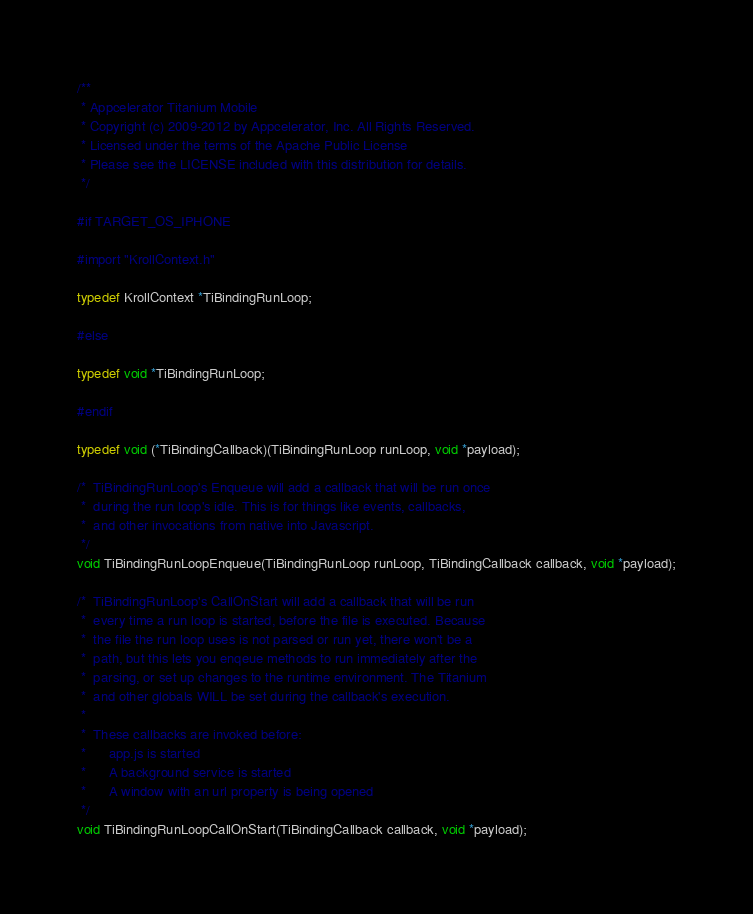<code> <loc_0><loc_0><loc_500><loc_500><_C_>/**
 * Appcelerator Titanium Mobile
 * Copyright (c) 2009-2012 by Appcelerator, Inc. All Rights Reserved.
 * Licensed under the terms of the Apache Public License
 * Please see the LICENSE included with this distribution for details.
 */

#if TARGET_OS_IPHONE

#import "KrollContext.h"

typedef KrollContext *TiBindingRunLoop;

#else

typedef void *TiBindingRunLoop;

#endif

typedef void (*TiBindingCallback)(TiBindingRunLoop runLoop, void *payload);

/*	TiBindingRunLoop's Enqueue will add a callback that will be run once
 *	during the run loop's idle. This is for things like events, callbacks,
 *	and other invocations from native into Javascript.
 */
void TiBindingRunLoopEnqueue(TiBindingRunLoop runLoop, TiBindingCallback callback, void *payload);

/*	TiBindingRunLoop's CallOnStart will add a callback that will be run
 *	every time a run loop is started, before the file is executed. Because
 *	the file the run loop uses is not parsed or run yet, there won't be a
 *	path, but this lets you enqeue methods to run immediately after the
 *	parsing, or set up changes to the runtime environment. The Titanium
 *	and other globals WILL be set during the callback's execution.
 *
 *	These callbacks are invoked before:
 *		app.js is started
 *		A background service is started
 *		A window with an url property is being opened
 */
void TiBindingRunLoopCallOnStart(TiBindingCallback callback, void *payload);
</code> 